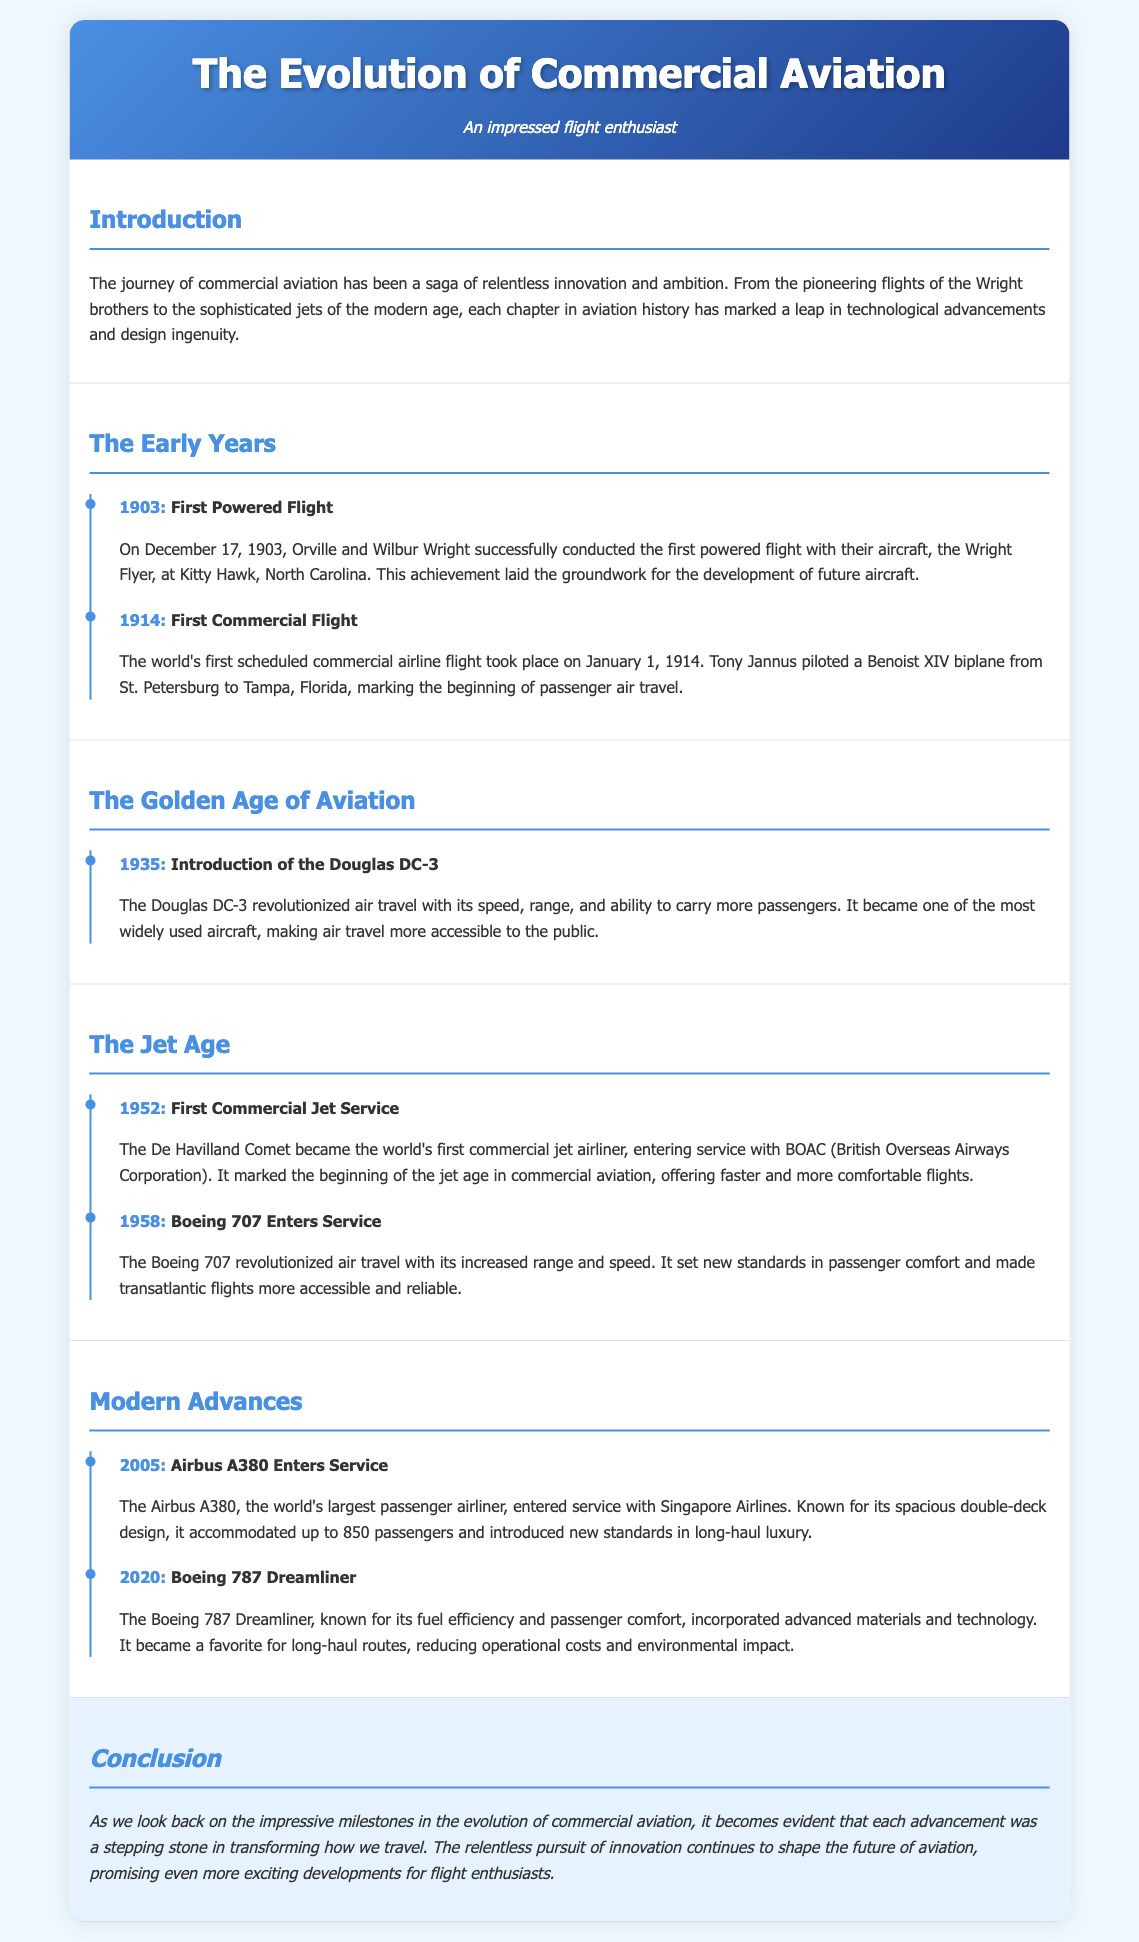What year did the Wright brothers conduct their first powered flight? The first powered flight by the Wright brothers took place on December 17, 1903.
Answer: 1903 What was the first scheduled commercial airline flight? The world's first scheduled commercial airline flight took place on January 1, 1914.
Answer: Benoist XIV biplane What aircraft revolutionized air travel in 1935? The introduction of the Douglas DC-3 in 1935 is noted for revolutionizing air travel.
Answer: Douglas DC-3 What milestone marked the beginning of the jet age in commercial aviation? The De Havilland Comet became the world's first commercial jet airliner in 1952.
Answer: First commercial jet service How many passengers could the Airbus A380 accommodate? The Airbus A380 could accommodate up to 850 passengers.
Answer: 850 In what year did the Boeing 787 Dreamliner become prominent? The Boeing 787 Dreamliner was noted in the document for 2020.
Answer: 2020 What was a key feature of the Boeing 707 that transformed air travel? The Boeing 707 set new standards in passenger comfort.
Answer: Passenger comfort What does the document conclude about advancements in aviation? The conclusion highlights that advancements shape the future of aviation.
Answer: Promise of exciting developments 